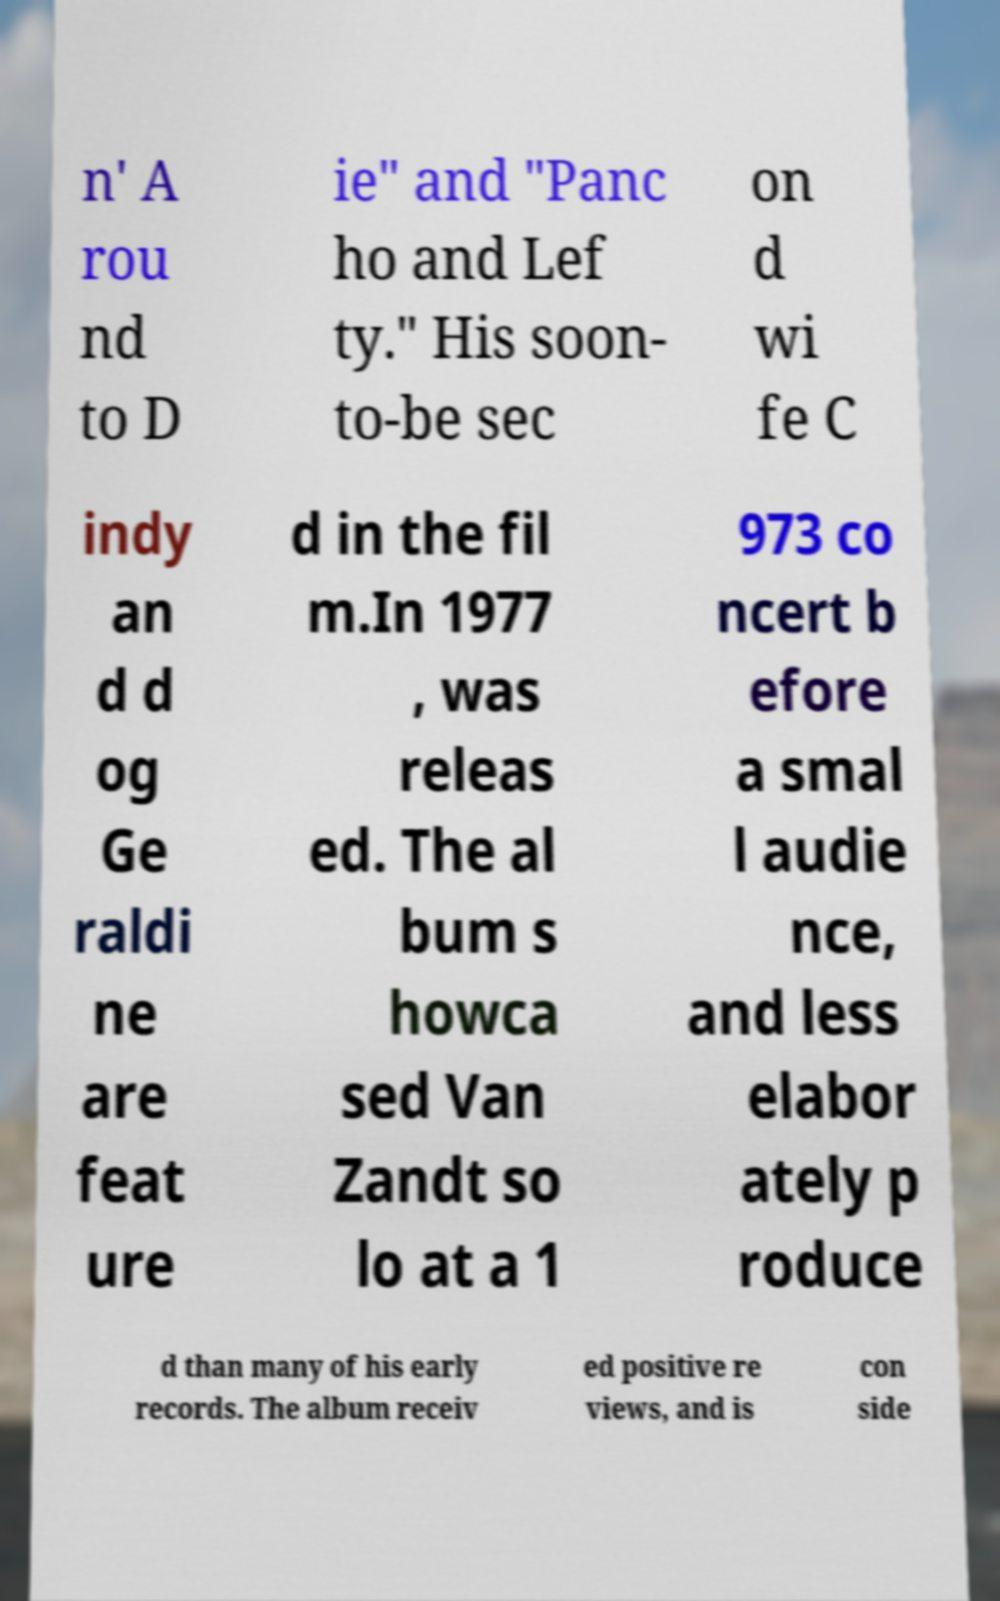Could you extract and type out the text from this image? n' A rou nd to D ie" and "Panc ho and Lef ty." His soon- to-be sec on d wi fe C indy an d d og Ge raldi ne are feat ure d in the fil m.In 1977 , was releas ed. The al bum s howca sed Van Zandt so lo at a 1 973 co ncert b efore a smal l audie nce, and less elabor ately p roduce d than many of his early records. The album receiv ed positive re views, and is con side 